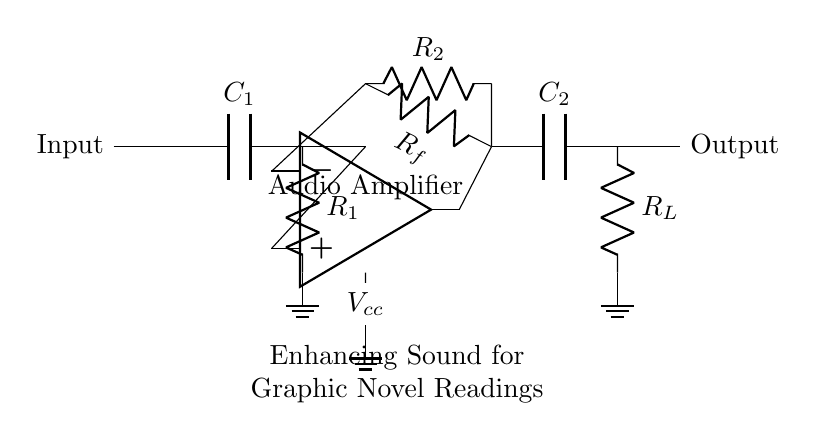What is the type of circuit shown? The circuit is an audio amplifier as indicated by the label. It is designed to enhance sound for better clarity during readings.
Answer: Audio amplifier What is the function of the capacitor C1? C1 is a coupling capacitor that allows AC signals (audio) to pass while blocking DC signals. This ensures the amplifier processes the audio signal effectively.
Answer: Coupling How many resistors are in the circuit? There are three resistors labeled R1, R2, and Rf. They are crucial for controlling the gain and feedback in the amplifier circuit.
Answer: Three What does Rf provide in this circuit? Rf is the feedback resistor, which helps determine the amplifier's gain and stability by feeding back a portion of the output signal to the inverting input of the op-amp.
Answer: Feedback What is the output component labeled as? The output component is labeled as Output, which signifies where the amplified audio signal will be sent for further processing or to speakers.
Answer: Output What is the voltage supply indicated in the circuit? The circuit uses a voltage supply labeled as Vcc, which powers the operational amplifier and is necessary for its function to amplify the audio signal.
Answer: Vcc 